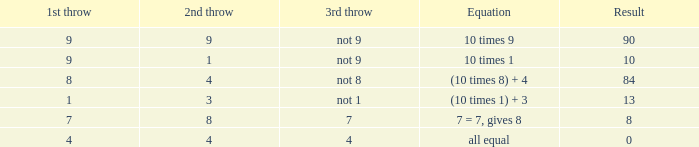If the equation is all equal, what is the 3rd throw? 4.0. 